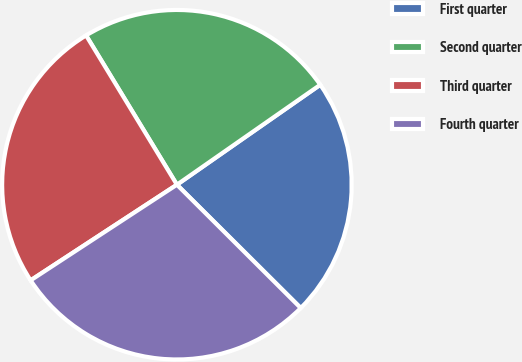<chart> <loc_0><loc_0><loc_500><loc_500><pie_chart><fcel>First quarter<fcel>Second quarter<fcel>Third quarter<fcel>Fourth quarter<nl><fcel>22.16%<fcel>24.01%<fcel>25.52%<fcel>28.32%<nl></chart> 